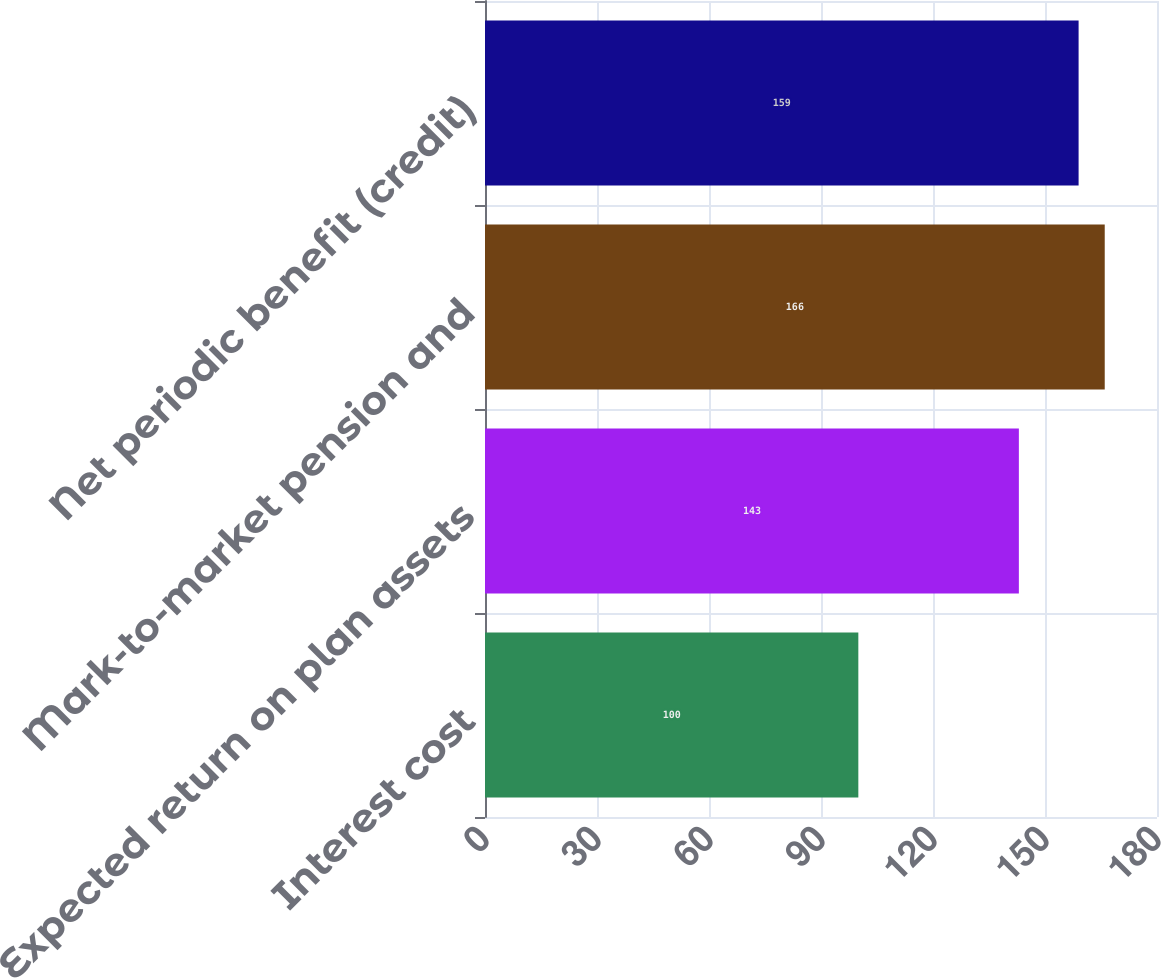<chart> <loc_0><loc_0><loc_500><loc_500><bar_chart><fcel>Interest cost<fcel>Expected return on plan assets<fcel>Mark-to-market pension and<fcel>Net periodic benefit (credit)<nl><fcel>100<fcel>143<fcel>166<fcel>159<nl></chart> 